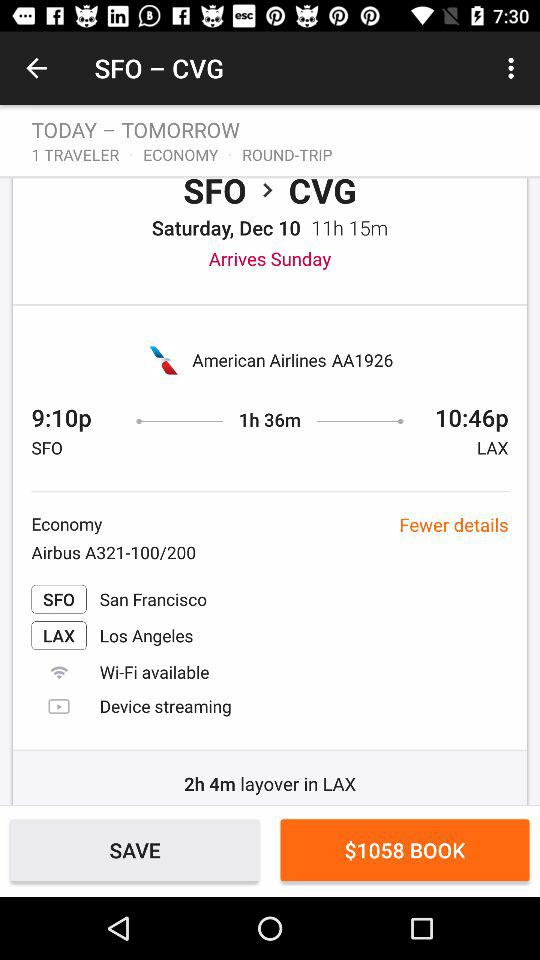What is the name of the LAX airport? The name of the LAX airport is Los Angeles. 